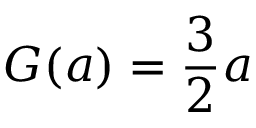Convert formula to latex. <formula><loc_0><loc_0><loc_500><loc_500>G ( a ) = \frac { 3 } { 2 } a</formula> 